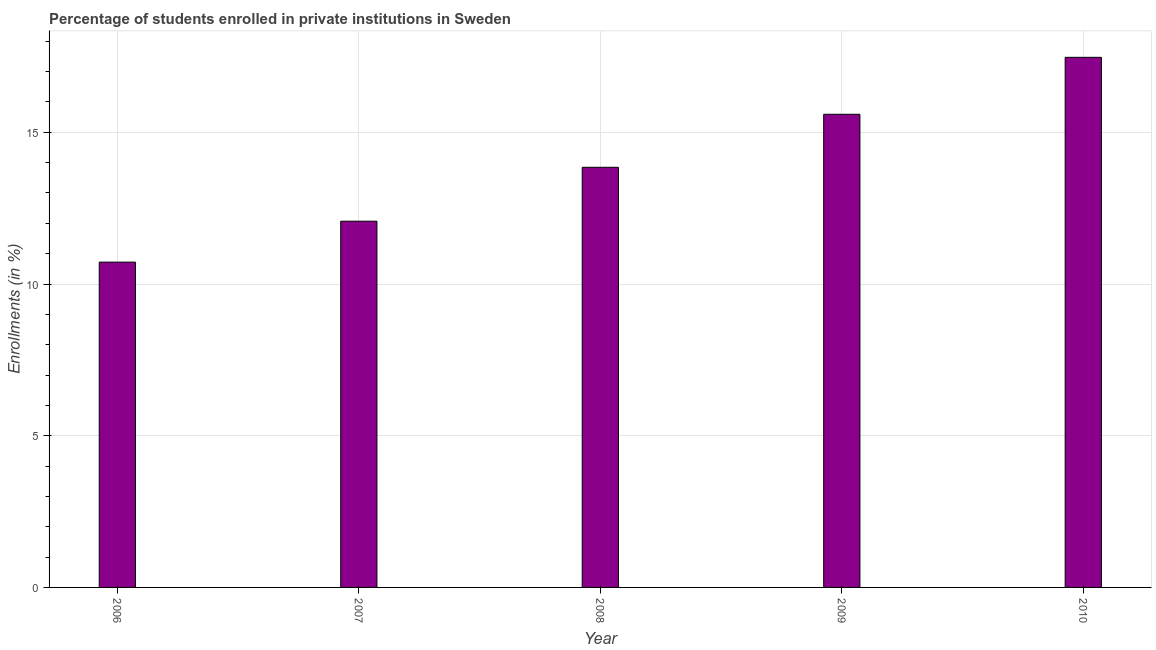What is the title of the graph?
Ensure brevity in your answer.  Percentage of students enrolled in private institutions in Sweden. What is the label or title of the X-axis?
Your response must be concise. Year. What is the label or title of the Y-axis?
Provide a succinct answer. Enrollments (in %). What is the enrollments in private institutions in 2006?
Provide a short and direct response. 10.72. Across all years, what is the maximum enrollments in private institutions?
Your answer should be very brief. 17.47. Across all years, what is the minimum enrollments in private institutions?
Make the answer very short. 10.72. In which year was the enrollments in private institutions minimum?
Provide a short and direct response. 2006. What is the sum of the enrollments in private institutions?
Make the answer very short. 69.7. What is the difference between the enrollments in private institutions in 2006 and 2008?
Give a very brief answer. -3.13. What is the average enrollments in private institutions per year?
Ensure brevity in your answer.  13.94. What is the median enrollments in private institutions?
Your answer should be very brief. 13.85. In how many years, is the enrollments in private institutions greater than 12 %?
Your answer should be compact. 4. Do a majority of the years between 2008 and 2006 (inclusive) have enrollments in private institutions greater than 1 %?
Give a very brief answer. Yes. What is the ratio of the enrollments in private institutions in 2008 to that in 2010?
Keep it short and to the point. 0.79. Is the difference between the enrollments in private institutions in 2006 and 2010 greater than the difference between any two years?
Offer a very short reply. Yes. What is the difference between the highest and the second highest enrollments in private institutions?
Ensure brevity in your answer.  1.88. What is the difference between the highest and the lowest enrollments in private institutions?
Your answer should be compact. 6.75. What is the Enrollments (in %) of 2006?
Provide a short and direct response. 10.72. What is the Enrollments (in %) of 2007?
Your answer should be very brief. 12.07. What is the Enrollments (in %) of 2008?
Keep it short and to the point. 13.85. What is the Enrollments (in %) of 2009?
Your response must be concise. 15.59. What is the Enrollments (in %) in 2010?
Provide a succinct answer. 17.47. What is the difference between the Enrollments (in %) in 2006 and 2007?
Provide a succinct answer. -1.35. What is the difference between the Enrollments (in %) in 2006 and 2008?
Offer a terse response. -3.13. What is the difference between the Enrollments (in %) in 2006 and 2009?
Offer a terse response. -4.87. What is the difference between the Enrollments (in %) in 2006 and 2010?
Your answer should be compact. -6.75. What is the difference between the Enrollments (in %) in 2007 and 2008?
Offer a terse response. -1.78. What is the difference between the Enrollments (in %) in 2007 and 2009?
Your answer should be very brief. -3.52. What is the difference between the Enrollments (in %) in 2007 and 2010?
Your response must be concise. -5.4. What is the difference between the Enrollments (in %) in 2008 and 2009?
Your answer should be very brief. -1.75. What is the difference between the Enrollments (in %) in 2008 and 2010?
Make the answer very short. -3.62. What is the difference between the Enrollments (in %) in 2009 and 2010?
Offer a terse response. -1.88. What is the ratio of the Enrollments (in %) in 2006 to that in 2007?
Provide a short and direct response. 0.89. What is the ratio of the Enrollments (in %) in 2006 to that in 2008?
Your answer should be compact. 0.77. What is the ratio of the Enrollments (in %) in 2006 to that in 2009?
Your answer should be compact. 0.69. What is the ratio of the Enrollments (in %) in 2006 to that in 2010?
Make the answer very short. 0.61. What is the ratio of the Enrollments (in %) in 2007 to that in 2008?
Offer a terse response. 0.87. What is the ratio of the Enrollments (in %) in 2007 to that in 2009?
Your answer should be very brief. 0.77. What is the ratio of the Enrollments (in %) in 2007 to that in 2010?
Provide a short and direct response. 0.69. What is the ratio of the Enrollments (in %) in 2008 to that in 2009?
Offer a very short reply. 0.89. What is the ratio of the Enrollments (in %) in 2008 to that in 2010?
Provide a short and direct response. 0.79. What is the ratio of the Enrollments (in %) in 2009 to that in 2010?
Make the answer very short. 0.89. 